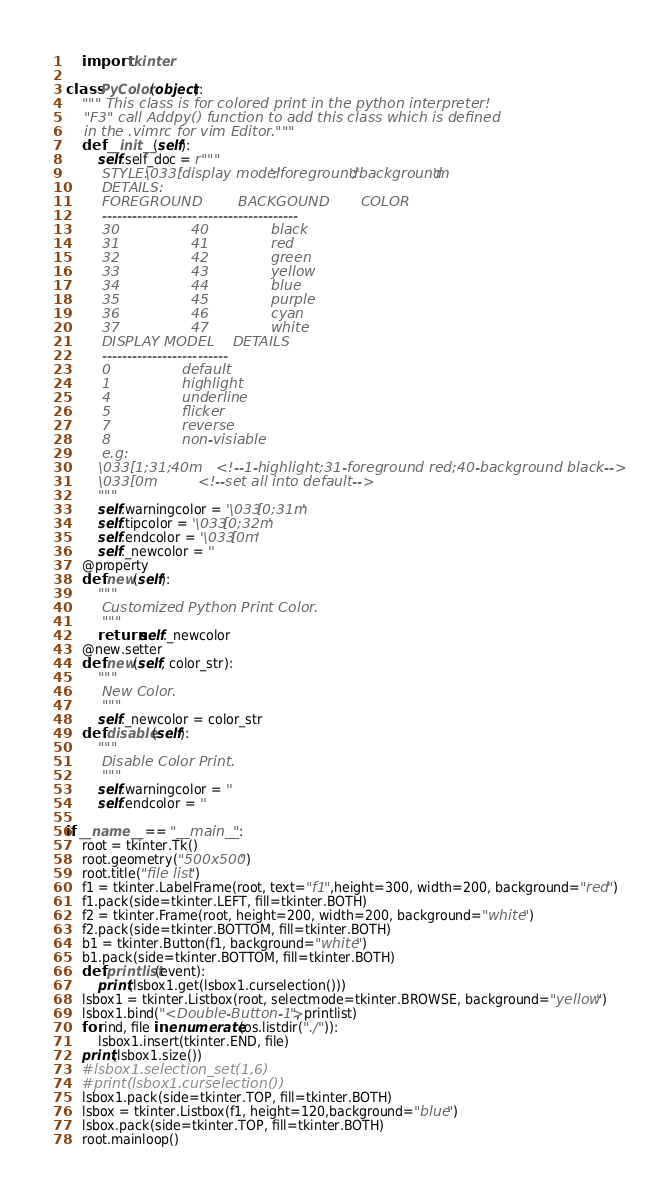Convert code to text. <code><loc_0><loc_0><loc_500><loc_500><_Python_>    import tkinter

class PyColor(object):
    """ This class is for colored print in the python interpreter!
    "F3" call Addpy() function to add this class which is defined
    in the .vimrc for vim Editor."""
    def __init__(self):
        self.self_doc = r"""
        STYLE: \033['display model';'foreground';'background'm
        DETAILS:
        FOREGROUND        BACKGOUND       COLOR
        ---------------------------------------
        30                40              black
        31                41              red
        32                42              green
        33                43              yellow
        34                44              blue
        35                45              purple
        36                46              cyan
        37                47              white
        DISPLAY MODEL    DETAILS
        -------------------------
        0                default
        1                highlight
        4                underline
        5                flicker
        7                reverse
        8                non-visiable
        e.g:
        \033[1;31;40m   <!--1-highlight;31-foreground red;40-background black-->
        \033[0m         <!--set all into default-->
        """
        self.warningcolor = '\033[0;31m'
        self.tipcolor = '\033[0;32m'
        self.endcolor = '\033[0m'
        self._newcolor = ''
    @property
    def new(self):
        """
        Customized Python Print Color.
        """
        return self._newcolor
    @new.setter
    def new(self, color_str):
        """
        New Color.
        """
        self._newcolor = color_str
    def disable(self):
        """
        Disable Color Print.
        """
        self.warningcolor = ''
        self.endcolor = ''

if __name__ == "__main__":
    root = tkinter.Tk()
    root.geometry("500x500")
    root.title("file list")
    f1 = tkinter.LabelFrame(root, text="f1",height=300, width=200, background="red")
    f1.pack(side=tkinter.LEFT, fill=tkinter.BOTH)
    f2 = tkinter.Frame(root, height=200, width=200, background="white")
    f2.pack(side=tkinter.BOTTOM, fill=tkinter.BOTH)
    b1 = tkinter.Button(f1, background="white")
    b1.pack(side=tkinter.BOTTOM, fill=tkinter.BOTH)
    def printlist(event):
        print(lsbox1.get(lsbox1.curselection()))
    lsbox1 = tkinter.Listbox(root, selectmode=tkinter.BROWSE, background="yellow")
    lsbox1.bind("<Double-Button-1>", printlist)
    for ind, file in enumerate(os.listdir("./")):
        lsbox1.insert(tkinter.END, file)
    print(lsbox1.size())
    #lsbox1.selection_set(1,6)
    #print(lsbox1.curselection())
    lsbox1.pack(side=tkinter.TOP, fill=tkinter.BOTH)
    lsbox = tkinter.Listbox(f1, height=120,background="blue")
    lsbox.pack(side=tkinter.TOP, fill=tkinter.BOTH)
    root.mainloop()
</code> 